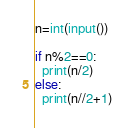Convert code to text. <code><loc_0><loc_0><loc_500><loc_500><_Python_>n=int(input())

if n%2==0:
  print(n/2)
else:
  print(n//2+1)</code> 